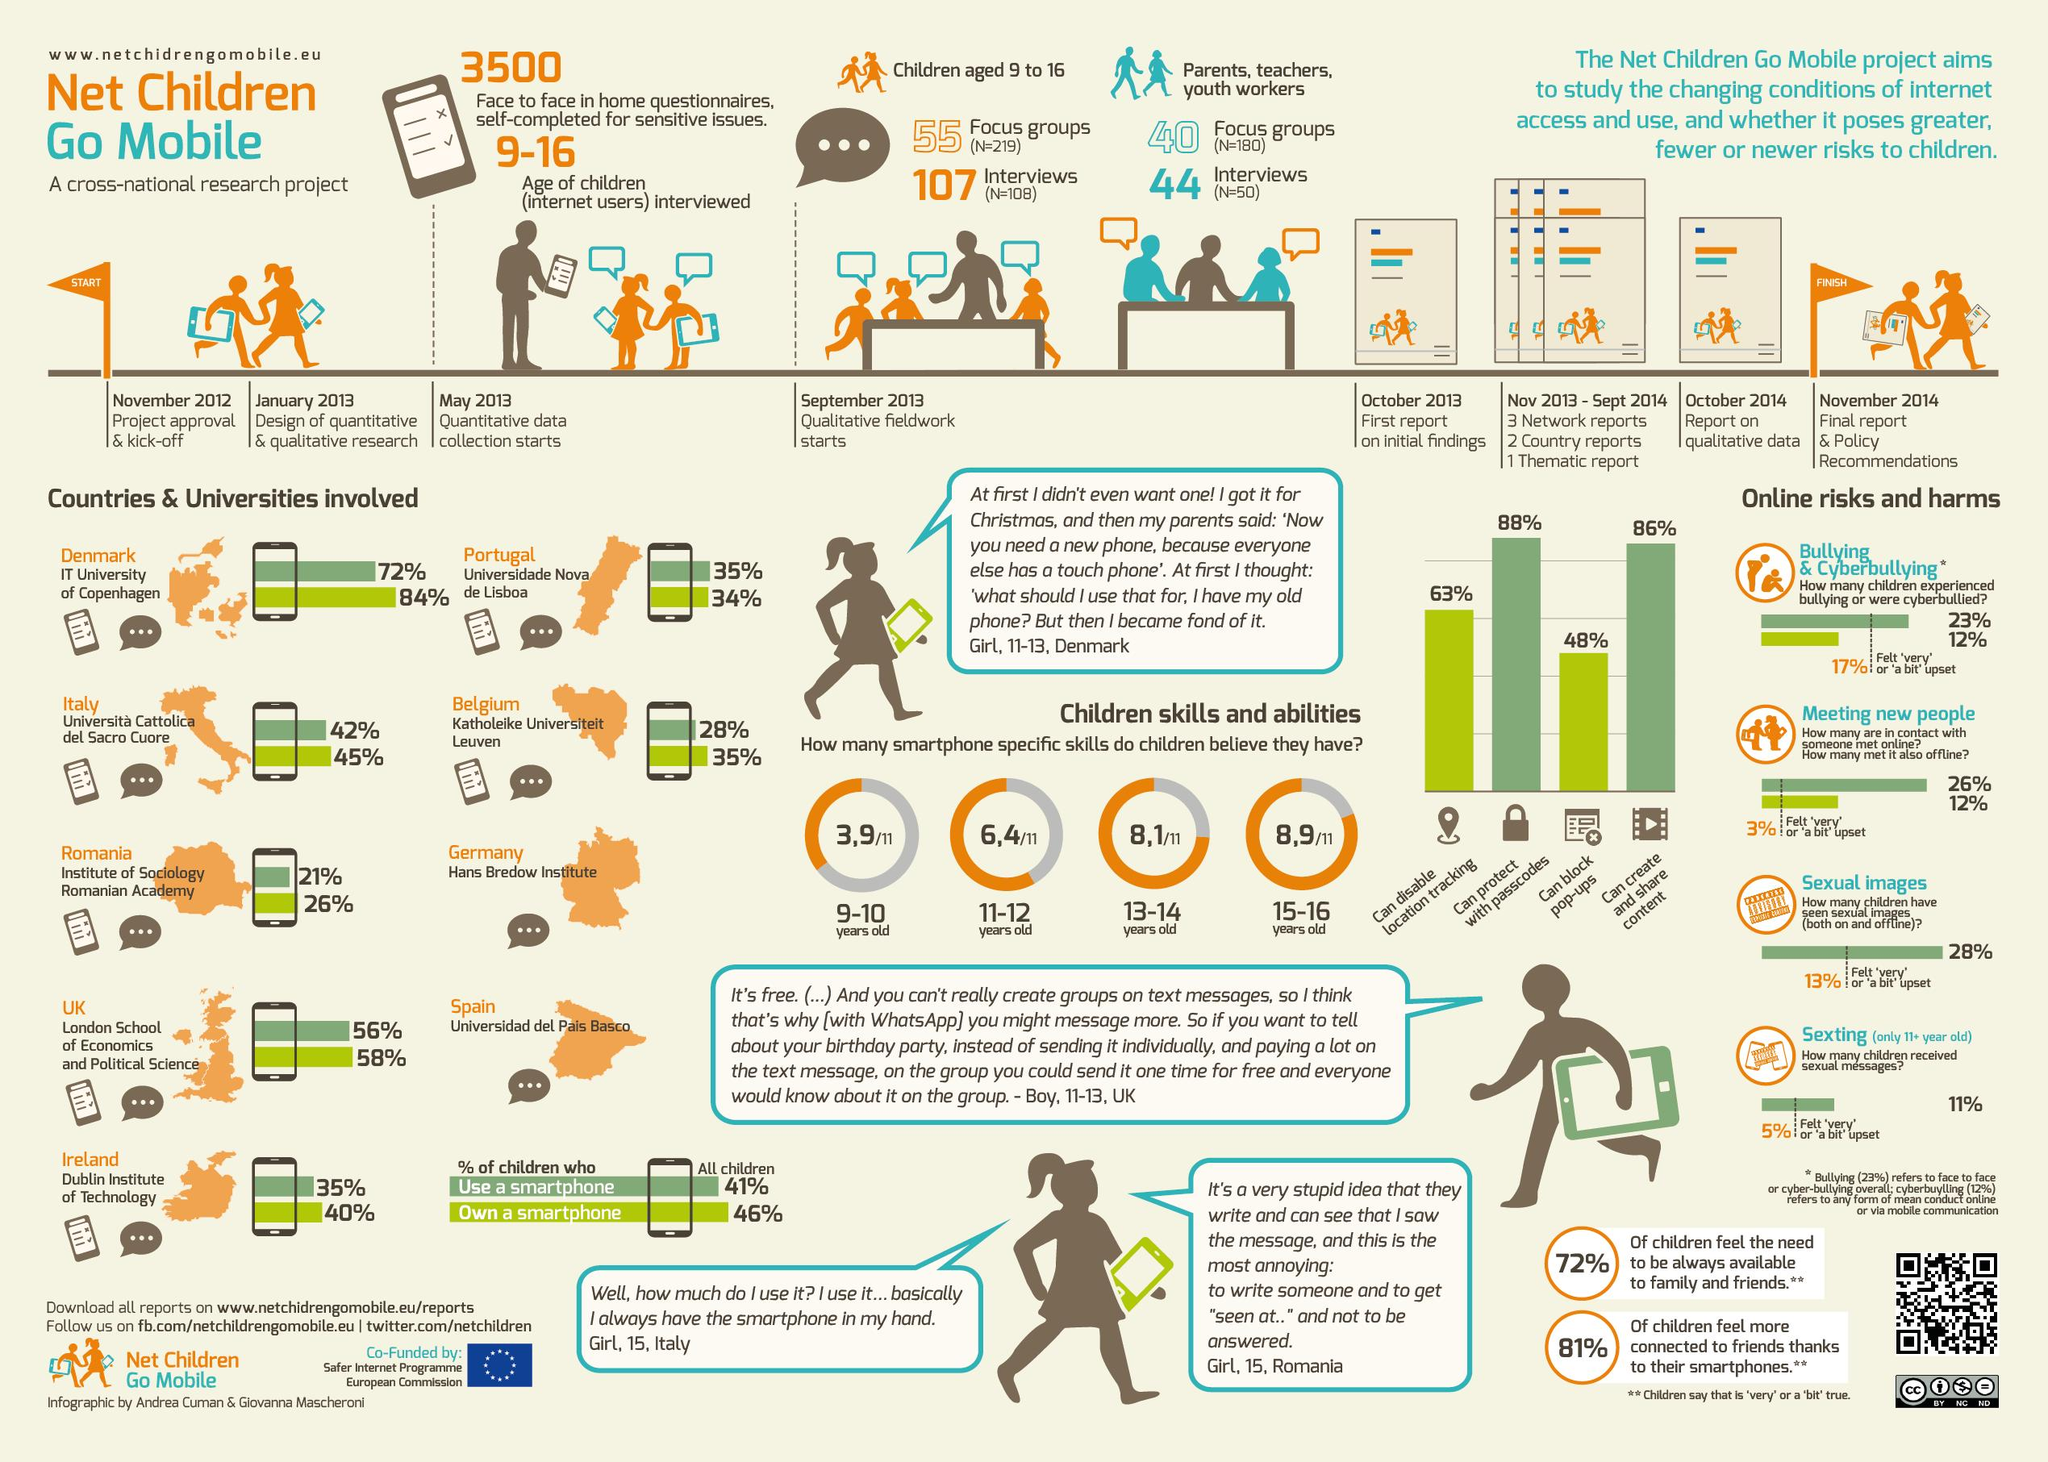Draw attention to some important aspects in this diagram. According to the Institute of Sociology at the Romanian Academy, a substantial 21% of children use smartphones. According to a recent survey, the IT University of Copenhagen has recorded the highest percentage of children using smartphones. According to the Institute of Sociology at the Romanian Academy, 26% of children in Romania own a smartphone. The Net Children Go Mobile project was initiated in November 2012. A study found that the average number of smartphone-specific skills possessed by children aged 13-14 is 8 out of 11 skills. 